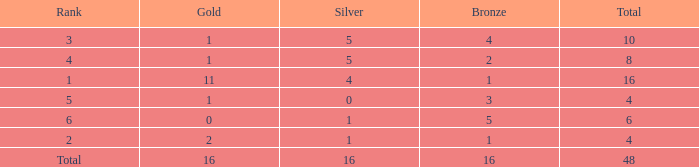How many gold are a rank 1 and larger than 16? 0.0. Could you parse the entire table? {'header': ['Rank', 'Gold', 'Silver', 'Bronze', 'Total'], 'rows': [['3', '1', '5', '4', '10'], ['4', '1', '5', '2', '8'], ['1', '11', '4', '1', '16'], ['5', '1', '0', '3', '4'], ['6', '0', '1', '5', '6'], ['2', '2', '1', '1', '4'], ['Total', '16', '16', '16', '48']]} 